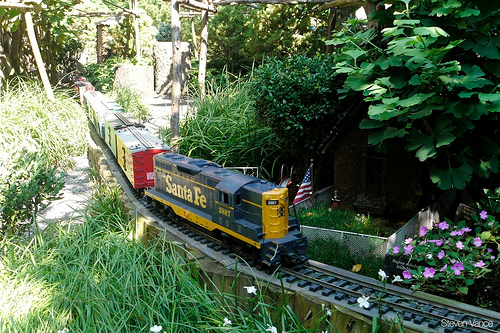What could be a story taking place in this scene? In a quaint little town hidden within fantastical greenery, the 'Santa Fe' train performs its daily rounds with utmost dedication. It is no ordinary train; it carries letters and supplies to fairy folk residing in the small houses scattered throughout the garden. One day, the train is entrusted with a special mission – delivering an invitation to a grand celebration in the enchanted forest. As the train chugs along, it passes through hidden groves and by sparkling streams, encountering various magical creatures. Each stop brings joy to the fairy folk, and anticipation builds for the grand event that promises to unite everyone in a magical celebration under the stars. Can you describe the surroundings in more detail? The surroundings of the train are a lush, green paradise. Tall bushes and brightly colored flowers encircle the tracks, their blooms contributing splashes of pink and other vibrant hues to the atmosphere. Hidden among the greenery and partially obscured by foliage, tiny houses with intricate details beckon curiosity. One small house, almost camouflaged, hints at a secret dwelling within this miniature world. The path is delicately framed with wooden structures, further enhancing the intimacy and intricacy of this enchanting garden. Every element – from perfectly placed stones to meticulously cared-for plants – speaks of a lovingly maintained sanctuary where magic and nature coexist. 